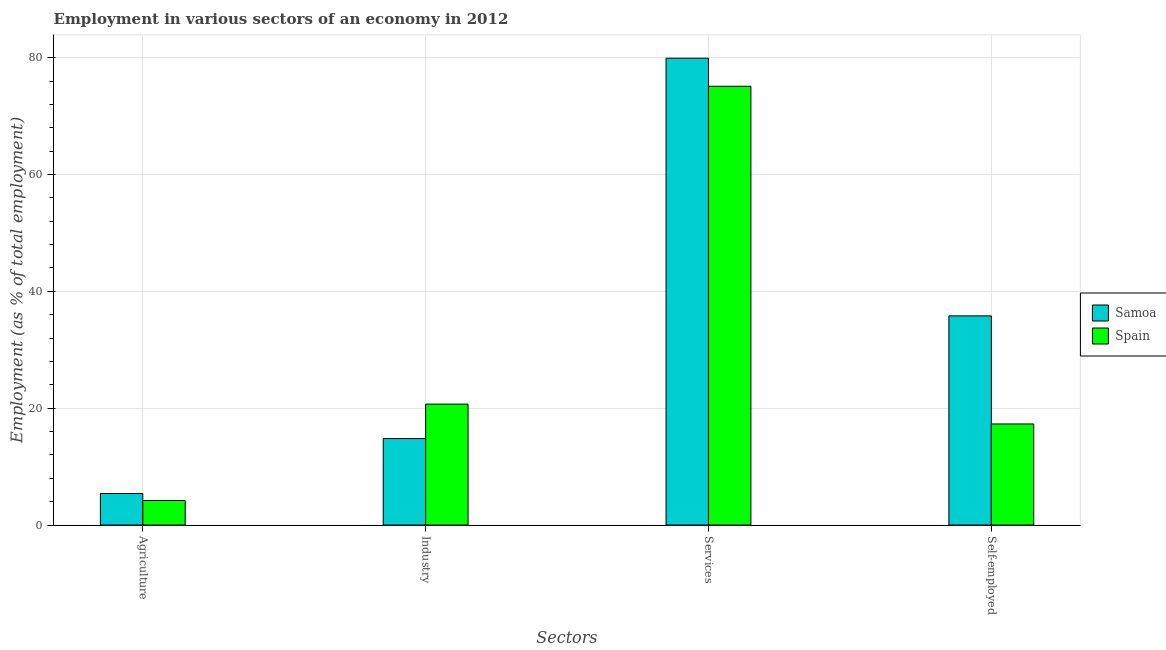How many different coloured bars are there?
Keep it short and to the point. 2. How many groups of bars are there?
Offer a terse response. 4. Are the number of bars per tick equal to the number of legend labels?
Provide a succinct answer. Yes. What is the label of the 3rd group of bars from the left?
Keep it short and to the point. Services. What is the percentage of workers in agriculture in Samoa?
Your answer should be compact. 5.4. Across all countries, what is the maximum percentage of workers in services?
Provide a short and direct response. 79.9. Across all countries, what is the minimum percentage of workers in services?
Offer a very short reply. 75.1. In which country was the percentage of workers in agriculture maximum?
Provide a short and direct response. Samoa. What is the total percentage of workers in agriculture in the graph?
Keep it short and to the point. 9.6. What is the difference between the percentage of workers in agriculture in Spain and that in Samoa?
Your answer should be very brief. -1.2. What is the difference between the percentage of workers in services in Spain and the percentage of workers in industry in Samoa?
Ensure brevity in your answer.  60.3. What is the average percentage of workers in industry per country?
Ensure brevity in your answer.  17.75. What is the difference between the percentage of workers in agriculture and percentage of self employed workers in Samoa?
Give a very brief answer. -30.4. What is the ratio of the percentage of workers in services in Samoa to that in Spain?
Make the answer very short. 1.06. Is the percentage of workers in agriculture in Spain less than that in Samoa?
Provide a short and direct response. Yes. What is the difference between the highest and the second highest percentage of workers in agriculture?
Give a very brief answer. 1.2. What is the difference between the highest and the lowest percentage of workers in agriculture?
Keep it short and to the point. 1.2. Is it the case that in every country, the sum of the percentage of self employed workers and percentage of workers in services is greater than the sum of percentage of workers in agriculture and percentage of workers in industry?
Your answer should be compact. Yes. What does the 2nd bar from the left in Self-employed represents?
Ensure brevity in your answer.  Spain. What does the 2nd bar from the right in Industry represents?
Offer a terse response. Samoa. Is it the case that in every country, the sum of the percentage of workers in agriculture and percentage of workers in industry is greater than the percentage of workers in services?
Give a very brief answer. No. How many bars are there?
Offer a terse response. 8. Are all the bars in the graph horizontal?
Your answer should be compact. No. What is the difference between two consecutive major ticks on the Y-axis?
Your answer should be very brief. 20. Does the graph contain any zero values?
Offer a terse response. No. Does the graph contain grids?
Offer a terse response. Yes. Where does the legend appear in the graph?
Your answer should be very brief. Center right. How are the legend labels stacked?
Make the answer very short. Vertical. What is the title of the graph?
Your response must be concise. Employment in various sectors of an economy in 2012. What is the label or title of the X-axis?
Your response must be concise. Sectors. What is the label or title of the Y-axis?
Offer a very short reply. Employment (as % of total employment). What is the Employment (as % of total employment) in Samoa in Agriculture?
Give a very brief answer. 5.4. What is the Employment (as % of total employment) of Spain in Agriculture?
Offer a terse response. 4.2. What is the Employment (as % of total employment) in Samoa in Industry?
Keep it short and to the point. 14.8. What is the Employment (as % of total employment) in Spain in Industry?
Offer a very short reply. 20.7. What is the Employment (as % of total employment) in Samoa in Services?
Offer a terse response. 79.9. What is the Employment (as % of total employment) of Spain in Services?
Keep it short and to the point. 75.1. What is the Employment (as % of total employment) in Samoa in Self-employed?
Offer a very short reply. 35.8. What is the Employment (as % of total employment) of Spain in Self-employed?
Provide a succinct answer. 17.3. Across all Sectors, what is the maximum Employment (as % of total employment) of Samoa?
Provide a short and direct response. 79.9. Across all Sectors, what is the maximum Employment (as % of total employment) in Spain?
Give a very brief answer. 75.1. Across all Sectors, what is the minimum Employment (as % of total employment) in Samoa?
Provide a short and direct response. 5.4. Across all Sectors, what is the minimum Employment (as % of total employment) in Spain?
Make the answer very short. 4.2. What is the total Employment (as % of total employment) in Samoa in the graph?
Keep it short and to the point. 135.9. What is the total Employment (as % of total employment) of Spain in the graph?
Your answer should be compact. 117.3. What is the difference between the Employment (as % of total employment) in Spain in Agriculture and that in Industry?
Provide a short and direct response. -16.5. What is the difference between the Employment (as % of total employment) in Samoa in Agriculture and that in Services?
Your answer should be very brief. -74.5. What is the difference between the Employment (as % of total employment) of Spain in Agriculture and that in Services?
Offer a terse response. -70.9. What is the difference between the Employment (as % of total employment) in Samoa in Agriculture and that in Self-employed?
Make the answer very short. -30.4. What is the difference between the Employment (as % of total employment) in Samoa in Industry and that in Services?
Give a very brief answer. -65.1. What is the difference between the Employment (as % of total employment) of Spain in Industry and that in Services?
Make the answer very short. -54.4. What is the difference between the Employment (as % of total employment) of Spain in Industry and that in Self-employed?
Your response must be concise. 3.4. What is the difference between the Employment (as % of total employment) in Samoa in Services and that in Self-employed?
Offer a terse response. 44.1. What is the difference between the Employment (as % of total employment) in Spain in Services and that in Self-employed?
Your response must be concise. 57.8. What is the difference between the Employment (as % of total employment) of Samoa in Agriculture and the Employment (as % of total employment) of Spain in Industry?
Your response must be concise. -15.3. What is the difference between the Employment (as % of total employment) of Samoa in Agriculture and the Employment (as % of total employment) of Spain in Services?
Provide a succinct answer. -69.7. What is the difference between the Employment (as % of total employment) in Samoa in Agriculture and the Employment (as % of total employment) in Spain in Self-employed?
Make the answer very short. -11.9. What is the difference between the Employment (as % of total employment) in Samoa in Industry and the Employment (as % of total employment) in Spain in Services?
Offer a very short reply. -60.3. What is the difference between the Employment (as % of total employment) in Samoa in Services and the Employment (as % of total employment) in Spain in Self-employed?
Keep it short and to the point. 62.6. What is the average Employment (as % of total employment) in Samoa per Sectors?
Give a very brief answer. 33.98. What is the average Employment (as % of total employment) of Spain per Sectors?
Your answer should be compact. 29.32. What is the difference between the Employment (as % of total employment) in Samoa and Employment (as % of total employment) in Spain in Agriculture?
Make the answer very short. 1.2. What is the difference between the Employment (as % of total employment) in Samoa and Employment (as % of total employment) in Spain in Industry?
Offer a very short reply. -5.9. What is the difference between the Employment (as % of total employment) of Samoa and Employment (as % of total employment) of Spain in Services?
Provide a succinct answer. 4.8. What is the difference between the Employment (as % of total employment) in Samoa and Employment (as % of total employment) in Spain in Self-employed?
Offer a terse response. 18.5. What is the ratio of the Employment (as % of total employment) of Samoa in Agriculture to that in Industry?
Your answer should be compact. 0.36. What is the ratio of the Employment (as % of total employment) of Spain in Agriculture to that in Industry?
Offer a very short reply. 0.2. What is the ratio of the Employment (as % of total employment) of Samoa in Agriculture to that in Services?
Your answer should be very brief. 0.07. What is the ratio of the Employment (as % of total employment) of Spain in Agriculture to that in Services?
Your answer should be compact. 0.06. What is the ratio of the Employment (as % of total employment) in Samoa in Agriculture to that in Self-employed?
Ensure brevity in your answer.  0.15. What is the ratio of the Employment (as % of total employment) in Spain in Agriculture to that in Self-employed?
Offer a terse response. 0.24. What is the ratio of the Employment (as % of total employment) of Samoa in Industry to that in Services?
Provide a short and direct response. 0.19. What is the ratio of the Employment (as % of total employment) of Spain in Industry to that in Services?
Offer a very short reply. 0.28. What is the ratio of the Employment (as % of total employment) of Samoa in Industry to that in Self-employed?
Offer a terse response. 0.41. What is the ratio of the Employment (as % of total employment) of Spain in Industry to that in Self-employed?
Ensure brevity in your answer.  1.2. What is the ratio of the Employment (as % of total employment) in Samoa in Services to that in Self-employed?
Your response must be concise. 2.23. What is the ratio of the Employment (as % of total employment) in Spain in Services to that in Self-employed?
Give a very brief answer. 4.34. What is the difference between the highest and the second highest Employment (as % of total employment) in Samoa?
Offer a terse response. 44.1. What is the difference between the highest and the second highest Employment (as % of total employment) in Spain?
Ensure brevity in your answer.  54.4. What is the difference between the highest and the lowest Employment (as % of total employment) of Samoa?
Your answer should be compact. 74.5. What is the difference between the highest and the lowest Employment (as % of total employment) in Spain?
Provide a short and direct response. 70.9. 